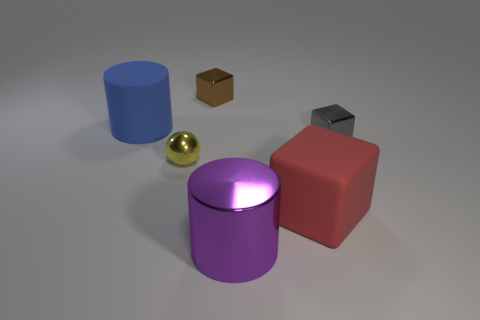Add 1 tiny yellow balls. How many objects exist? 7 Subtract all spheres. How many objects are left? 5 Add 6 large metallic cylinders. How many large metallic cylinders exist? 7 Subtract 0 purple blocks. How many objects are left? 6 Subtract all tiny gray cubes. Subtract all cyan matte blocks. How many objects are left? 5 Add 6 shiny balls. How many shiny balls are left? 7 